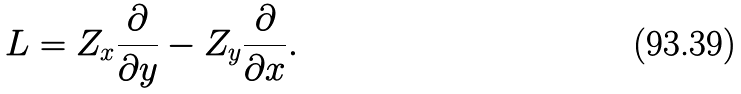<formula> <loc_0><loc_0><loc_500><loc_500>L = Z _ { x } \frac { \partial } { \partial y } - Z _ { y } \frac { \partial } { \partial x } .</formula> 